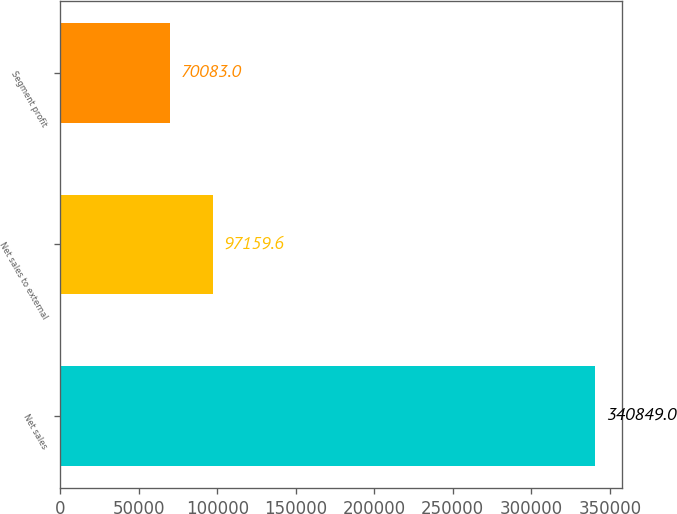Convert chart to OTSL. <chart><loc_0><loc_0><loc_500><loc_500><bar_chart><fcel>Net sales<fcel>Net sales to external<fcel>Segment profit<nl><fcel>340849<fcel>97159.6<fcel>70083<nl></chart> 